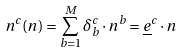Convert formula to latex. <formula><loc_0><loc_0><loc_500><loc_500>n ^ { c } ( { n } ) = \sum _ { b = 1 } ^ { M } \delta ^ { c } _ { b } \cdot n ^ { b } = { \underline { e } } ^ { c } \cdot { n }</formula> 